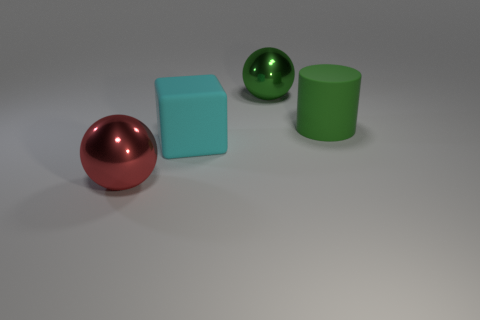What number of objects are large metallic objects that are left of the big green metal object or shiny things in front of the green sphere?
Your answer should be very brief. 1. There is a green cylinder that is the same size as the cyan thing; what is it made of?
Your answer should be very brief. Rubber. The large cylinder has what color?
Provide a short and direct response. Green. There is a large thing that is both behind the large matte cube and to the left of the big green matte object; what is it made of?
Offer a terse response. Metal. There is a big shiny sphere left of the rubber object left of the green cylinder; is there a metal ball that is right of it?
Offer a very short reply. Yes. There is a shiny sphere that is the same color as the cylinder; what size is it?
Provide a short and direct response. Large. There is a big cyan matte block; are there any big red metal balls in front of it?
Your answer should be very brief. Yes. What number of other things are the same shape as the big cyan rubber thing?
Make the answer very short. 0. There is a cylinder that is the same size as the cube; what is its color?
Ensure brevity in your answer.  Green. Is the number of metal spheres left of the big cyan rubber block less than the number of big metallic balls to the left of the large green matte object?
Your answer should be compact. Yes. 